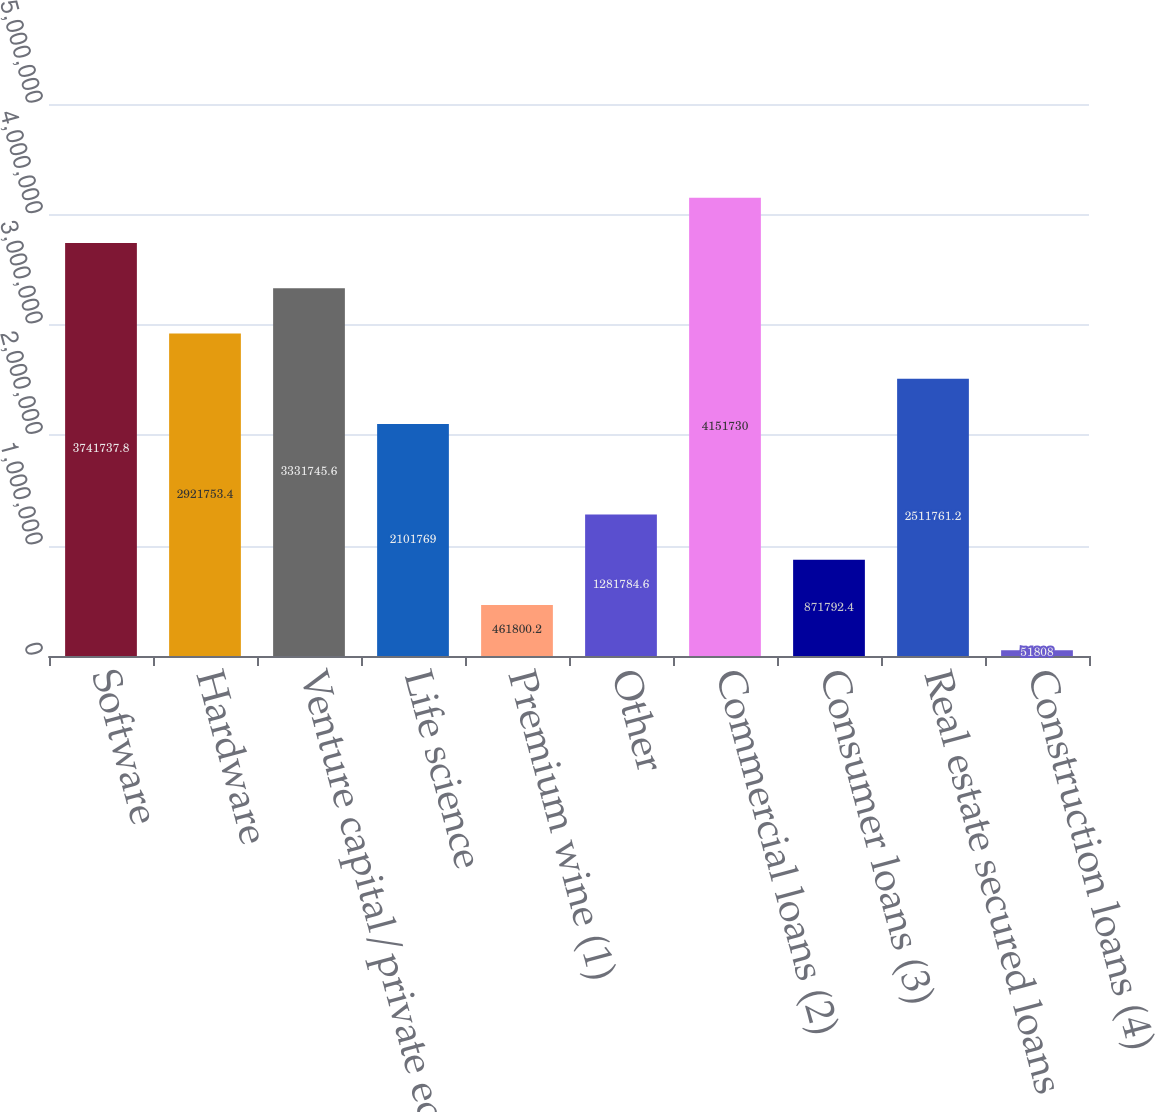Convert chart to OTSL. <chart><loc_0><loc_0><loc_500><loc_500><bar_chart><fcel>Software<fcel>Hardware<fcel>Venture capital/private equity<fcel>Life science<fcel>Premium wine (1)<fcel>Other<fcel>Commercial loans (2)<fcel>Consumer loans (3)<fcel>Real estate secured loans<fcel>Construction loans (4)<nl><fcel>3.74174e+06<fcel>2.92175e+06<fcel>3.33175e+06<fcel>2.10177e+06<fcel>461800<fcel>1.28178e+06<fcel>4.15173e+06<fcel>871792<fcel>2.51176e+06<fcel>51808<nl></chart> 